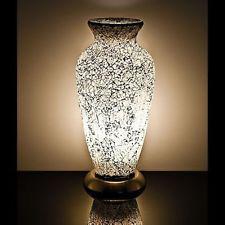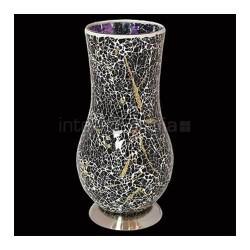The first image is the image on the left, the second image is the image on the right. Evaluate the accuracy of this statement regarding the images: "One lamp is shaped like an urn with a solid black base, while a second lamp has a rounded lower half that narrows before flaring slightly at the top, and sits on a silver base.". Is it true? Answer yes or no. Yes. The first image is the image on the left, the second image is the image on the right. Examine the images to the left and right. Is the description "A vase is displayed against a plain black background." accurate? Answer yes or no. Yes. 